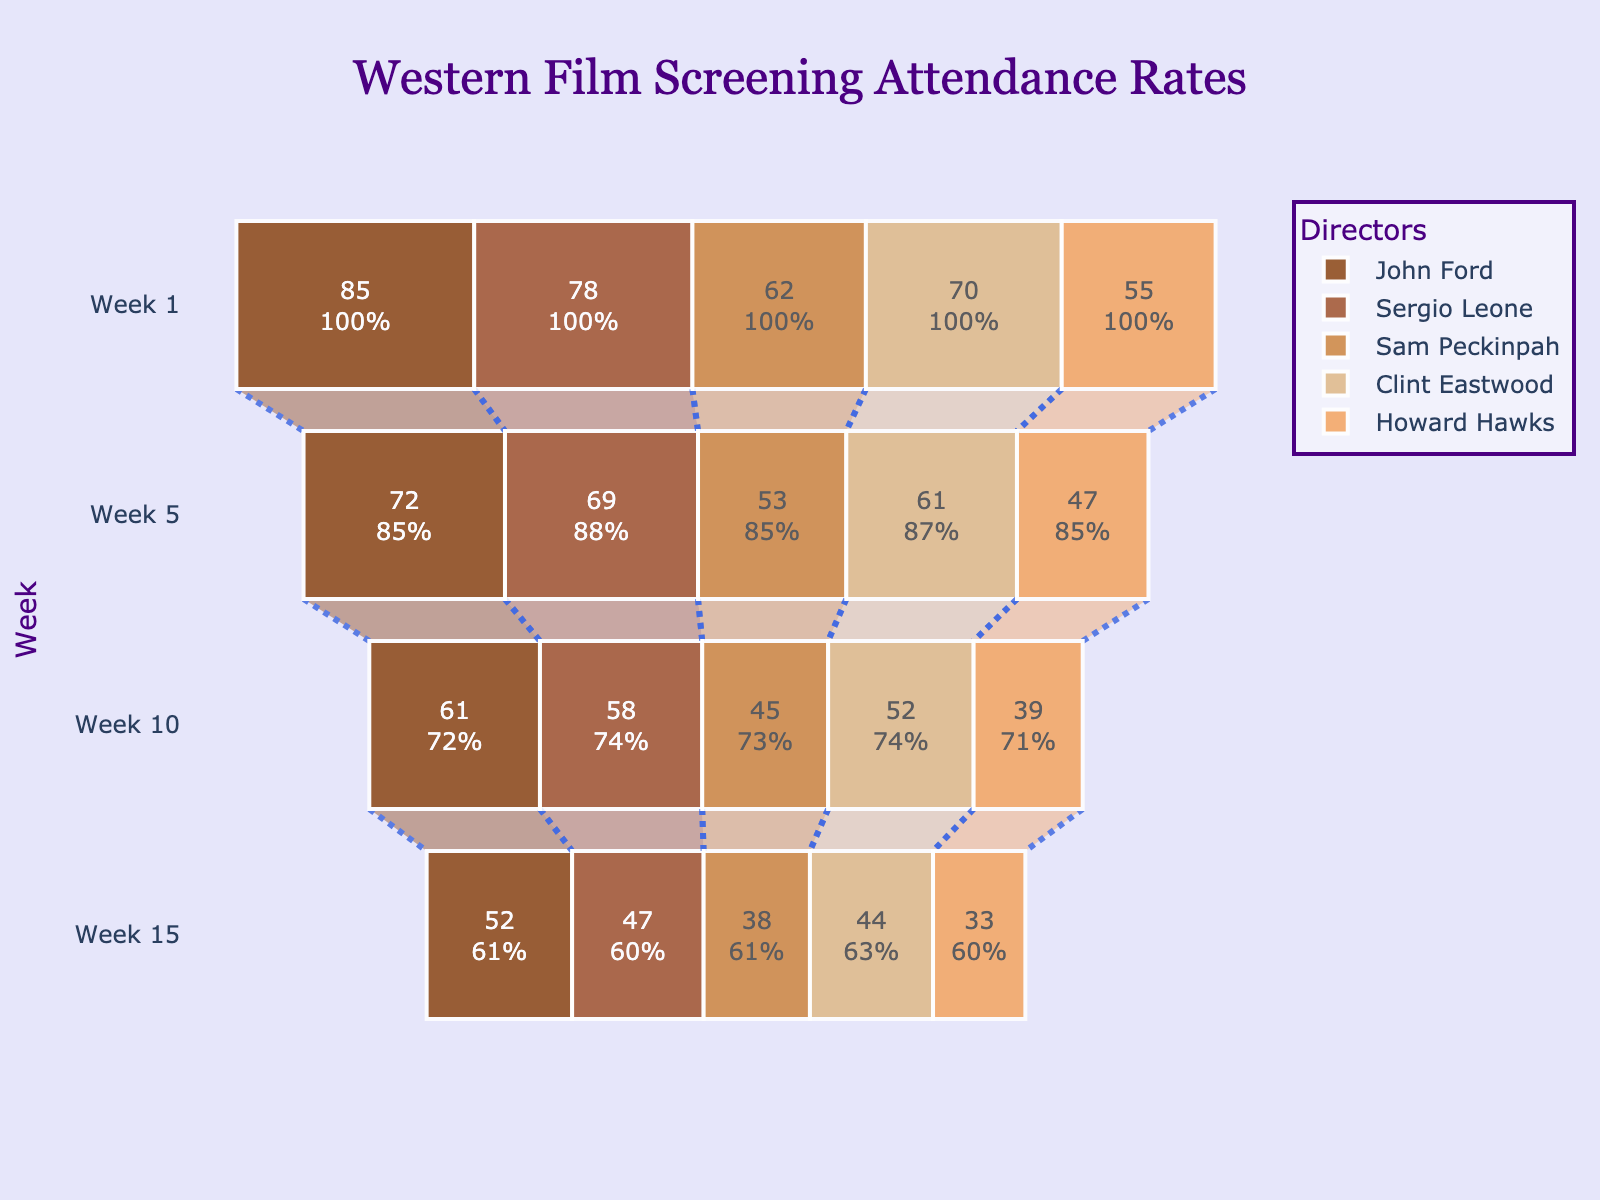What is the title of the plot? The title can be found at the top of the chart, which provides an overview of what the data represents.
Answer: Western Film Screening Attendance Rates How many directors are shown in the funnel chart? Each director is represented by a different color in the chart. By counting them, we can see there are five directors listed.
Answer: 5 Which director had the highest attendance in Week 1? Look at the widest part of the funnel at Week 1 for each director and identify the highest number. John Ford has the largest attendance.
Answer: John Ford What was the attendance rate for Howard Hawks in Week 10? Find Howard Hawks's funnel section at Week 10, indicated by the corresponding color and week label, showing the attendance number.
Answer: 39 By how much did attendance drop for Sergio Leone from Week 1 to Week 15? Subtract the attendance in Week 15 from the attendance in Week 1 for Sergio Leone. The calculation is 78 - 47.
Answer: 31 Which director had the smallest decrease in attendance from Week 1 to Week 5? Calculate the drop in attendance for each director between Week 1 and Week 5, then find the smallest decrease: John Ford (13), Sergio Leone (9), Sam Peckinpah (9), Clint Eastwood (9), Howard Hawks (8).
Answer: Howard Hawks Who had a higher attendance in Week 10, Clint Eastwood or Sam Peckinpah? Compare the attendance numbers in Week 10 for both directors. Clint Eastwood had an attendance of 52, and Sam Peckinpah had 45.
Answer: Clint Eastwood Which week had the highest overall attendance across all directors? Sum the attendance rates across all directors for each week: Week 1 (85+78+62+70+55=350), Week 5 (72+69+53+61+47=302), Week 10 (61+58+45+52+39=255), Week 15 (52+47+38+44+33=214).
Answer: Week 1 By what percentage did John Ford's attendance drop from Week 1 to Week 15? Calculate the percentage drop using the formula: ((Week 1 - Week 15) / Week 1) * 100. So ((85 - 52) / 85) * 100 = 38.82%.
Answer: 38.82% Which director's attendance fell below 50 first, and in which week? Look for the week in which each director first falls below an attendance of 50. Howard Hawks fell below 50 in Week 1 with 55 dropping to 47 by Week 5.
Answer: Howard Hawks, Week 5 